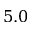<formula> <loc_0><loc_0><loc_500><loc_500>5 . 0</formula> 